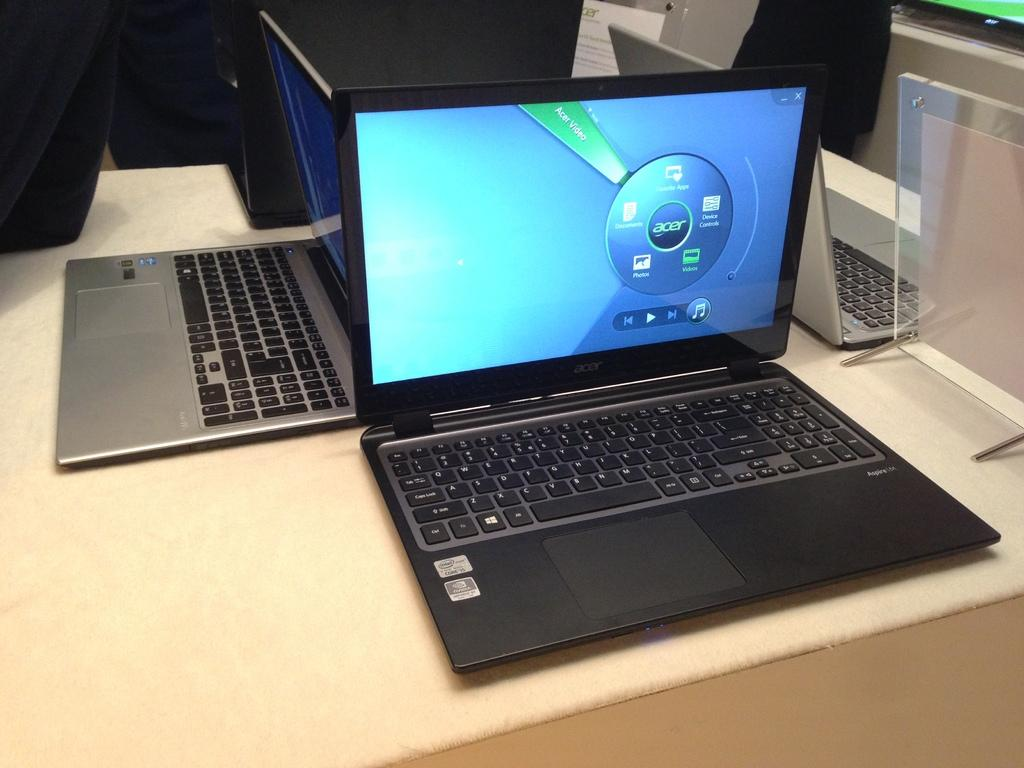<image>
Provide a brief description of the given image. Laptop from Acer that has a blue screen with multimedia icons. 